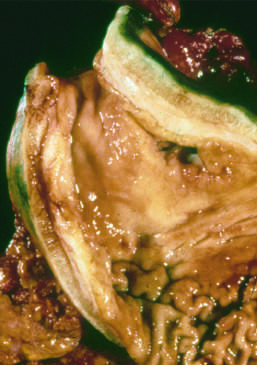re the rugal fold partially lost?
Answer the question using a single word or phrase. Yes 